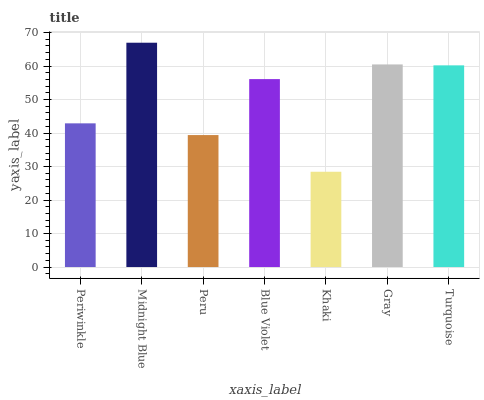Is Khaki the minimum?
Answer yes or no. Yes. Is Midnight Blue the maximum?
Answer yes or no. Yes. Is Peru the minimum?
Answer yes or no. No. Is Peru the maximum?
Answer yes or no. No. Is Midnight Blue greater than Peru?
Answer yes or no. Yes. Is Peru less than Midnight Blue?
Answer yes or no. Yes. Is Peru greater than Midnight Blue?
Answer yes or no. No. Is Midnight Blue less than Peru?
Answer yes or no. No. Is Blue Violet the high median?
Answer yes or no. Yes. Is Blue Violet the low median?
Answer yes or no. Yes. Is Midnight Blue the high median?
Answer yes or no. No. Is Midnight Blue the low median?
Answer yes or no. No. 